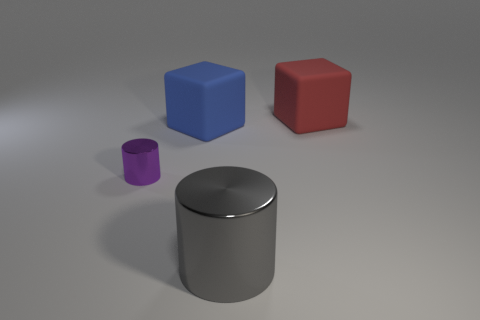There is a big red thing; what number of purple metal objects are behind it?
Your answer should be compact. 0. How many objects are either metal objects that are right of the tiny metal object or brown rubber cylinders?
Your answer should be very brief. 1. Is the number of large gray metallic cylinders that are in front of the big red object greater than the number of large blue matte blocks in front of the blue rubber block?
Keep it short and to the point. Yes. Do the red matte block and the metallic thing behind the big metal cylinder have the same size?
Give a very brief answer. No. What number of cylinders are large rubber objects or small metallic objects?
Provide a short and direct response. 1. There is a red thing that is the same material as the blue thing; what is its size?
Offer a terse response. Large. There is a metal object that is to the right of the purple cylinder; is its size the same as the matte thing that is left of the red object?
Keep it short and to the point. Yes. What number of objects are either brown cubes or large red things?
Offer a very short reply. 1. What is the shape of the red matte object?
Keep it short and to the point. Cube. The purple metallic object that is the same shape as the gray metallic thing is what size?
Make the answer very short. Small. 